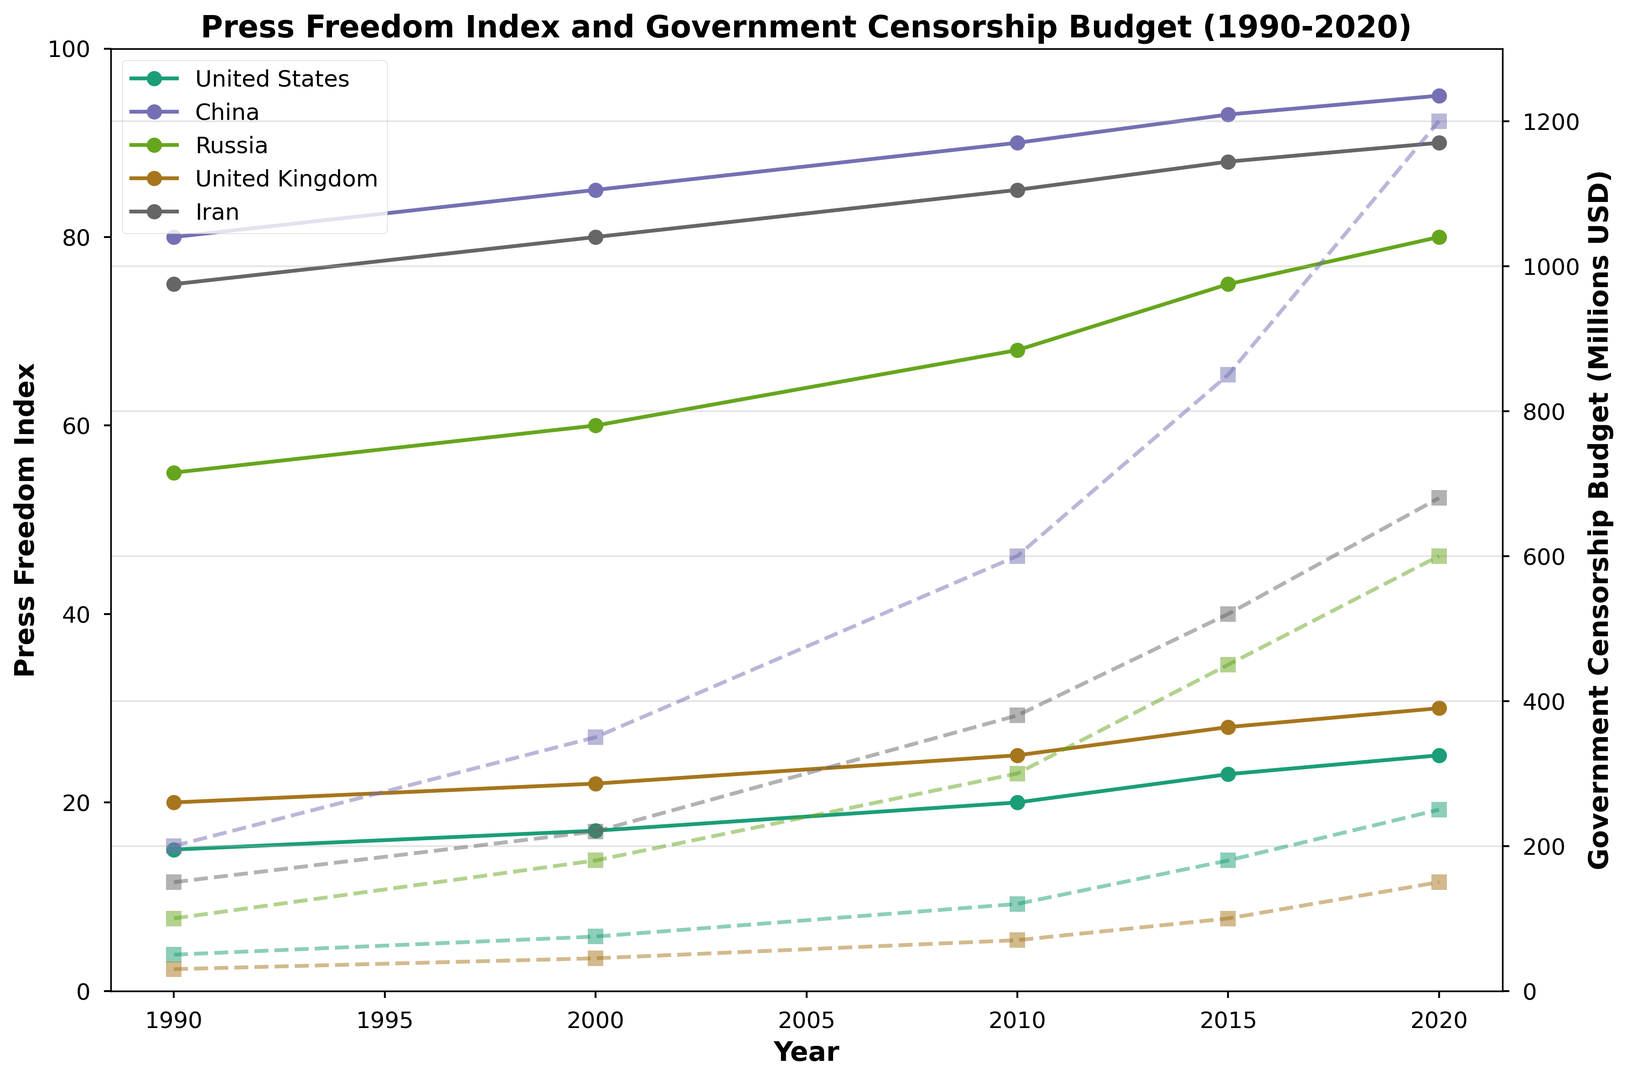What country had the highest Press Freedom Index in 2020? By looking at the Press Freedom Index line for 2020, we can see that China has the highest value.
Answer: China Which country saw the largest increase in its Government Censorship Budget from 1990 to 2020? To determine the largest increase, subtract the 1990 values from the 2020 values for each country. China’s budget increased from 200 to 1200 million USD, the largest increment.
Answer: China How did the Press Freedom Index for Russia change from 1990 to 2020? Checking the Press Freedom Index for Russia, it increased from 55 in 1990 to 80 in 2020.
Answer: It increased In 2010, which country had the lowest Government Censorship Budget, and what was the budget? By observing the 2010 line, the United Kingdom had the lowest Government Censorship Budget, which was 70 million USD.
Answer: United Kingdom, 70 million USD Did the United States’ Press Freedom Index improve or worsen from 1990 to 2020? Comparing the indices, the United States' Press Freedom Index worsened from 15 in 1990 to 25 in 2020.
Answer: It worsened What was the trend in the Press Freedom Index for Iran from 1990 to 2020? Observing the plot, Iran’s Press Freedom Index fluctuated but generally increased from 75 in 1990 to 90 in 2020.
Answer: It generally increased Which two countries had the closest Government Censorship Budgets in 2000, and what were those budgets? Observing the 2000 data, the United Kingdom (45 million USD) and Iran (220 million USD) have more similar orders of magnitude, but Iran and Russia (180 million USD) are closer in absolute terms.
Answer: Russia and Iran, 180 million USD and 220 million USD What was the percentage increase in China's Government Censorship Budget from 2010 to 2020? Subtract the 2010 value from the 2020 value and divide by the 2010 value, then multiply by 100. (1200 - 600) / 600 * 100 = 100%
Answer: 100% Between 2015 and 2020, which country had the smallest change in Press Freedom Index? Comparing the indices, the United States changed from 23 to 25, a difference of 2, which is the smallest.
Answer: United States Which country had the steepest rise in Government Censorship Budget between any two consecutive decades? By visually assessing the plot, China’s budget between each consecutive decade shows the steepest rise, particularly from 2010 to 2020.
Answer: China 